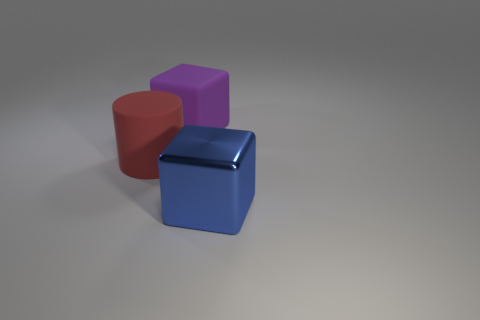There is a metal cube that is the same size as the red rubber cylinder; what color is it? The metal cube in the image shares the same dimensions as the red rubber cylinder positioned to its left, and it has a sleek blue finish, which gives it a striking appearance against the neutral background. 